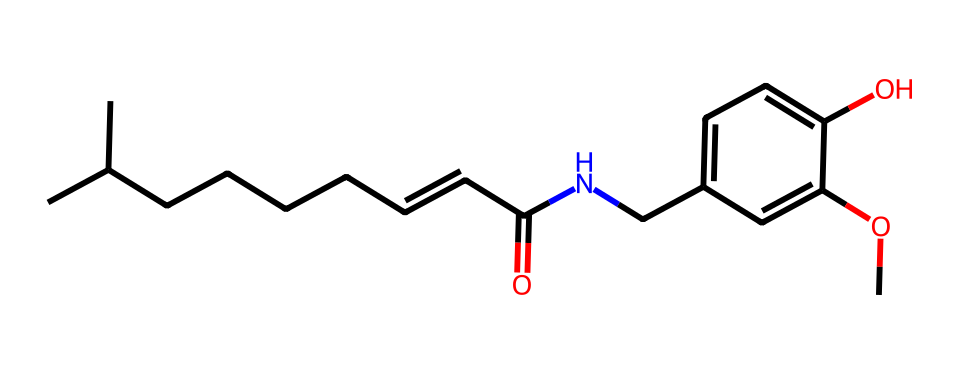What is the total number of carbon atoms in capsaicin? To find the total number of carbon atoms, you can count the carbon atoms in the SMILES representation. In the given structure, there are 12 carbon atoms indicated.
Answer: 12 How many hydroxyl (–OH) groups are in this chemical? The hydroxyl group is represented by 'O' connected to 'c' in the SMILES representation. In this structure, there is one hydroxyl group present.
Answer: 1 What functional group is present in capsaicin? Looking at the SMILES, there is a –OH group attached to a carbon ring, which indicates the presence of a phenolic group, typical for phenols.
Answer: phenolic group What is the longest carbon chain in capsaicin? By examining the structure, the longest continuous chain of carbon atoms is a straight chain of six carbons, including the branching methyl group.
Answer: six Which part of the molecule contributes to its spicy heat? The amide functional group (–C(=O)N–) plays a crucial role in contributing to spiciness. Understanding the interaction of the nitrogen and acid part elucidates its heat character.
Answer: amide group What is the degree of unsaturation in capsaicin? You can determine the degree of unsaturation by calculating (2n + 2 - x) where n is the number of carbons and x is the number of hydrogens. For capsaicin, it has three degrees of unsaturation, due to the double bond and the aromatic ring.
Answer: three 